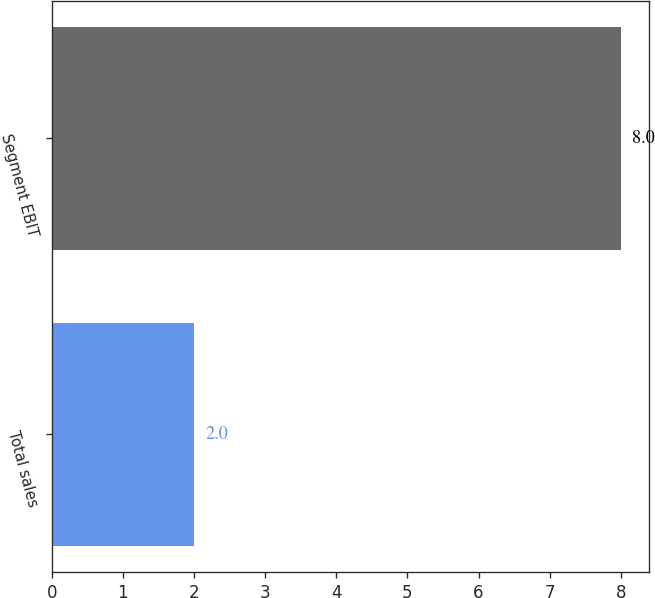Convert chart. <chart><loc_0><loc_0><loc_500><loc_500><bar_chart><fcel>Total sales<fcel>Segment EBIT<nl><fcel>2<fcel>8<nl></chart> 